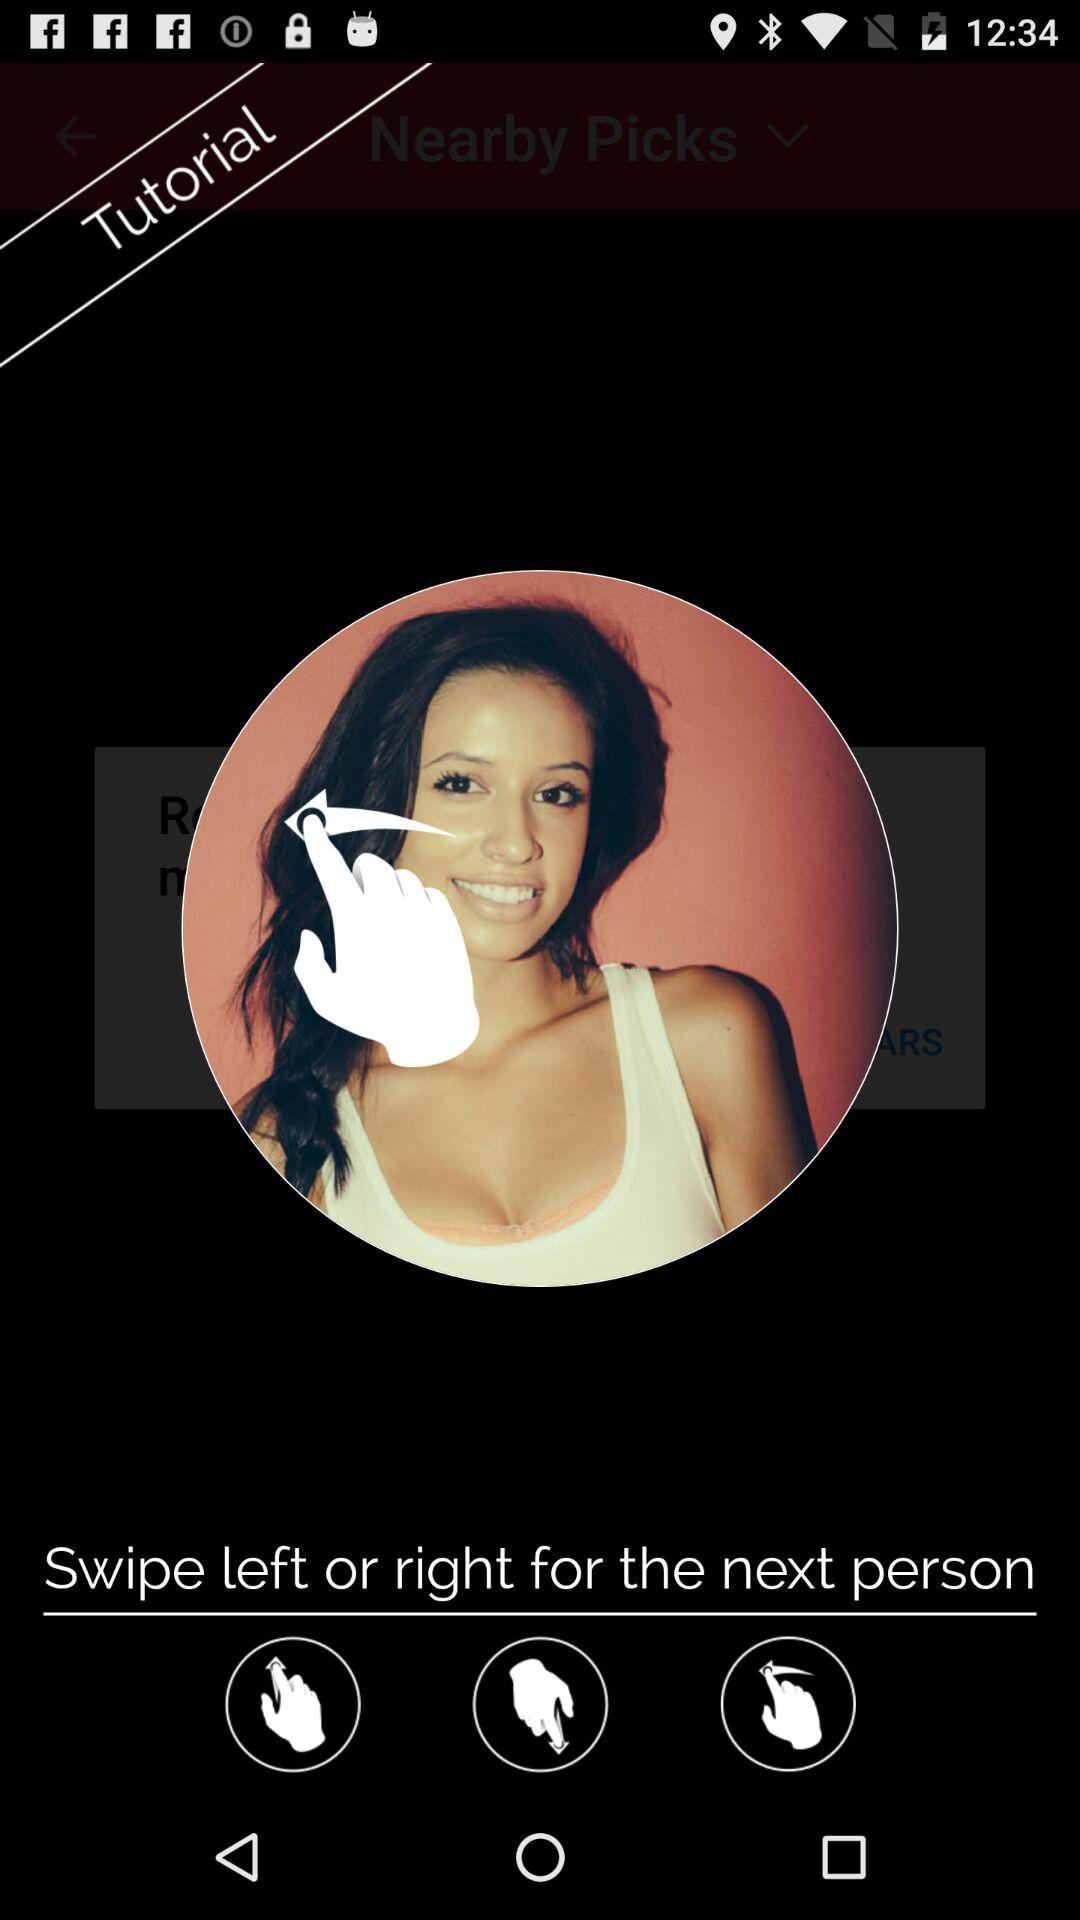What is the username?
When the provided information is insufficient, respond with <no answer>. <no answer> 